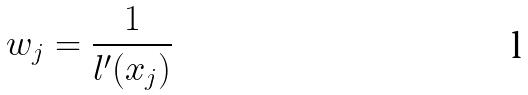<formula> <loc_0><loc_0><loc_500><loc_500>w _ { j } = \frac { 1 } { l ^ { \prime } ( x _ { j } ) }</formula> 